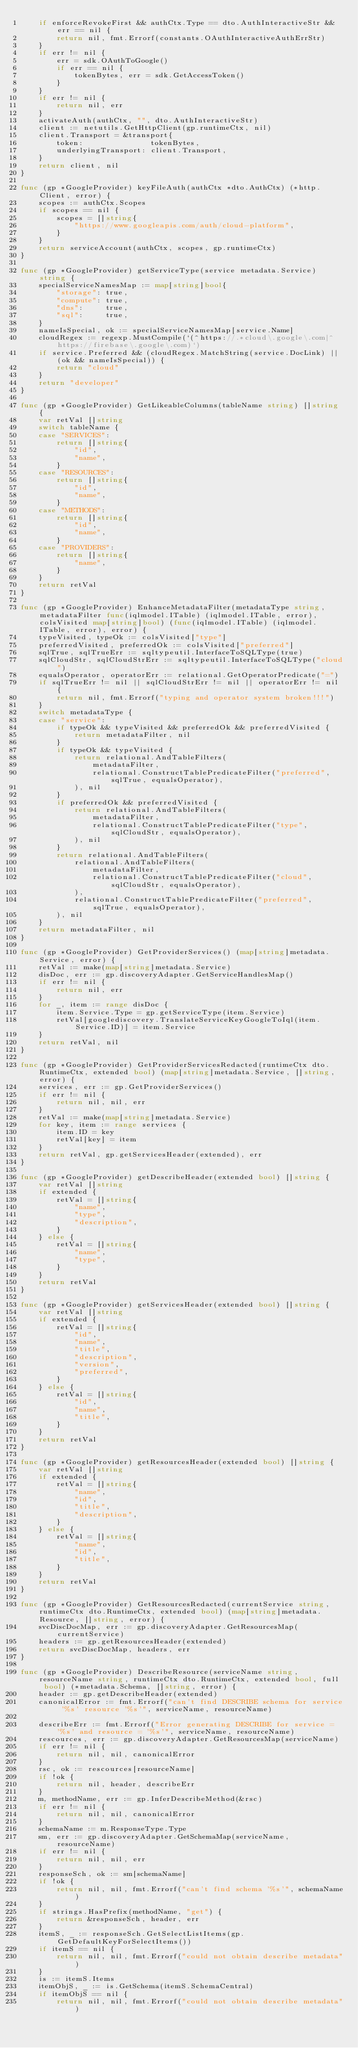Convert code to text. <code><loc_0><loc_0><loc_500><loc_500><_Go_>	if enforceRevokeFirst && authCtx.Type == dto.AuthInteractiveStr && err == nil {
		return nil, fmt.Errorf(constants.OAuthInteractiveAuthErrStr)
	}
	if err != nil {
		err = sdk.OAuthToGoogle()
		if err == nil {
			tokenBytes, err = sdk.GetAccessToken()
		}
	}
	if err != nil {
		return nil, err
	}
	activateAuth(authCtx, "", dto.AuthInteractiveStr)
	client := netutils.GetHttpClient(gp.runtimeCtx, nil)
	client.Transport = &transport{
		token:               tokenBytes,
		underlyingTransport: client.Transport,
	}
	return client, nil
}

func (gp *GoogleProvider) keyFileAuth(authCtx *dto.AuthCtx) (*http.Client, error) {
	scopes := authCtx.Scopes
	if scopes == nil {
		scopes = []string{
			"https://www.googleapis.com/auth/cloud-platform",
		}
	}
	return serviceAccount(authCtx, scopes, gp.runtimeCtx)
}

func (gp *GoogleProvider) getServiceType(service metadata.Service) string {
	specialServiceNamesMap := map[string]bool{
		"storage": true,
		"compute": true,
		"dns":     true,
		"sql":     true,
	}
	nameIsSpecial, ok := specialServiceNamesMap[service.Name]
	cloudRegex := regexp.MustCompile(`(^https://.*cloud\.google\.com|^https://firebase\.google\.com)`)
	if service.Preferred && (cloudRegex.MatchString(service.DocLink) || (ok && nameIsSpecial)) {
		return "cloud"
	}
	return "developer"
}

func (gp *GoogleProvider) GetLikeableColumns(tableName string) []string {
	var retVal []string
	switch tableName {
	case "SERVICES":
		return []string{
			"id",
			"name",
		}
	case "RESOURCES":
		return []string{
			"id",
			"name",
		}
	case "METHODS":
		return []string{
			"id",
			"name",
		}
	case "PROVIDERS":
		return []string{
			"name",
		}
	}
	return retVal
}

func (gp *GoogleProvider) EnhanceMetadataFilter(metadataType string, metadataFilter func(iqlmodel.ITable) (iqlmodel.ITable, error), colsVisited map[string]bool) (func(iqlmodel.ITable) (iqlmodel.ITable, error), error) {
	typeVisited, typeOk := colsVisited["type"]
	preferredVisited, preferredOk := colsVisited["preferred"]
	sqlTrue, sqlTrueErr := sqltypeutil.InterfaceToSQLType(true)
	sqlCloudStr, sqlCloudStrErr := sqltypeutil.InterfaceToSQLType("cloud")
	equalsOperator, operatorErr := relational.GetOperatorPredicate("=")
	if sqlTrueErr != nil || sqlCloudStrErr != nil || operatorErr != nil {
		return nil, fmt.Errorf("typing and operator system broken!!!")
	}
	switch metadataType {
	case "service":
		if typeOk && typeVisited && preferredOk && preferredVisited {
			return metadataFilter, nil
		}
		if typeOk && typeVisited {
			return relational.AndTableFilters(
				metadataFilter,
				relational.ConstructTablePredicateFilter("preferred", sqlTrue, equalsOperator),
			), nil
		}
		if preferredOk && preferredVisited {
			return relational.AndTableFilters(
				metadataFilter,
				relational.ConstructTablePredicateFilter("type", sqlCloudStr, equalsOperator),
			), nil
		}
		return relational.AndTableFilters(
			relational.AndTableFilters(
				metadataFilter,
				relational.ConstructTablePredicateFilter("cloud", sqlCloudStr, equalsOperator),
			),
			relational.ConstructTablePredicateFilter("preferred", sqlTrue, equalsOperator),
		), nil
	}
	return metadataFilter, nil
}

func (gp *GoogleProvider) GetProviderServices() (map[string]metadata.Service, error) {
	retVal := make(map[string]metadata.Service)
	disDoc, err := gp.discoveryAdapter.GetServiceHandlesMap()
	if err != nil {
		return nil, err
	}
	for _, item := range disDoc {
		item.Service.Type = gp.getServiceType(item.Service)
		retVal[googlediscovery.TranslateServiceKeyGoogleToIql(item.Service.ID)] = item.Service
	}
	return retVal, nil
}

func (gp *GoogleProvider) GetProviderServicesRedacted(runtimeCtx dto.RuntimeCtx, extended bool) (map[string]metadata.Service, []string, error) {
	services, err := gp.GetProviderServices()
	if err != nil {
		return nil, nil, err
	}
	retVal := make(map[string]metadata.Service)
	for key, item := range services {
		item.ID = key
		retVal[key] = item
	}
	return retVal, gp.getServicesHeader(extended), err
}

func (gp *GoogleProvider) getDescribeHeader(extended bool) []string {
	var retVal []string
	if extended {
		retVal = []string{
			"name",
			"type",
			"description",
		}
	} else {
		retVal = []string{
			"name",
			"type",
		}
	}
	return retVal
}

func (gp *GoogleProvider) getServicesHeader(extended bool) []string {
	var retVal []string
	if extended {
		retVal = []string{
			"id",
			"name",
			"title",
			"description",
			"version",
			"preferred",
		}
	} else {
		retVal = []string{
			"id",
			"name",
			"title",
		}
	}
	return retVal
}

func (gp *GoogleProvider) getResourcesHeader(extended bool) []string {
	var retVal []string
	if extended {
		retVal = []string{
			"name",
			"id",
			"title",
			"description",
		}
	} else {
		retVal = []string{
			"name",
			"id",
			"title",
		}
	}
	return retVal
}

func (gp *GoogleProvider) GetResourcesRedacted(currentService string, runtimeCtx dto.RuntimeCtx, extended bool) (map[string]metadata.Resource, []string, error) {
	svcDiscDocMap, err := gp.discoveryAdapter.GetResourcesMap(currentService)
	headers := gp.getResourcesHeader(extended)
	return svcDiscDocMap, headers, err
}

func (gp *GoogleProvider) DescribeResource(serviceName string, resourceName string, runtimeCtx dto.RuntimeCtx, extended bool, full bool) (*metadata.Schema, []string, error) {
	header := gp.getDescribeHeader(extended)
	canonicalError := fmt.Errorf("can't find DESCRIBE schema for service '%s' resource '%s'", serviceName, resourceName)

	describeErr := fmt.Errorf("Error generating DESCRIBE for service = '%s' and resource = '%s'", serviceName, resourceName)
	rescources, err := gp.discoveryAdapter.GetResourcesMap(serviceName)
	if err != nil {
		return nil, nil, canonicalError
	}
	rsc, ok := rescources[resourceName]
	if !ok {
		return nil, header, describeErr
	}
	m, methodName, err := gp.InferDescribeMethod(&rsc)
	if err != nil {
		return nil, nil, canonicalError
	}
	schemaName := m.ResponseType.Type
	sm, err := gp.discoveryAdapter.GetSchemaMap(serviceName, resourceName)
	if err != nil {
		return nil, nil, err
	}
	responseSch, ok := sm[schemaName]
	if !ok {
		return nil, nil, fmt.Errorf("can't find schema '%s'", schemaName)
	}
	if strings.HasPrefix(methodName, "get") {
		return &responseSch, header, err
	}
	itemS, _ := responseSch.GetSelectListItems(gp.GetDefaultKeyForSelectItems())
	if itemS == nil {
		return nil, nil, fmt.Errorf("could not obtain describe metadata")
	}
	is := itemS.Items
	itemObjS, _ := is.GetSchema(itemS.SchemaCentral)
	if itemObjS == nil {
		return nil, nil, fmt.Errorf("could not obtain describe metadata")</code> 